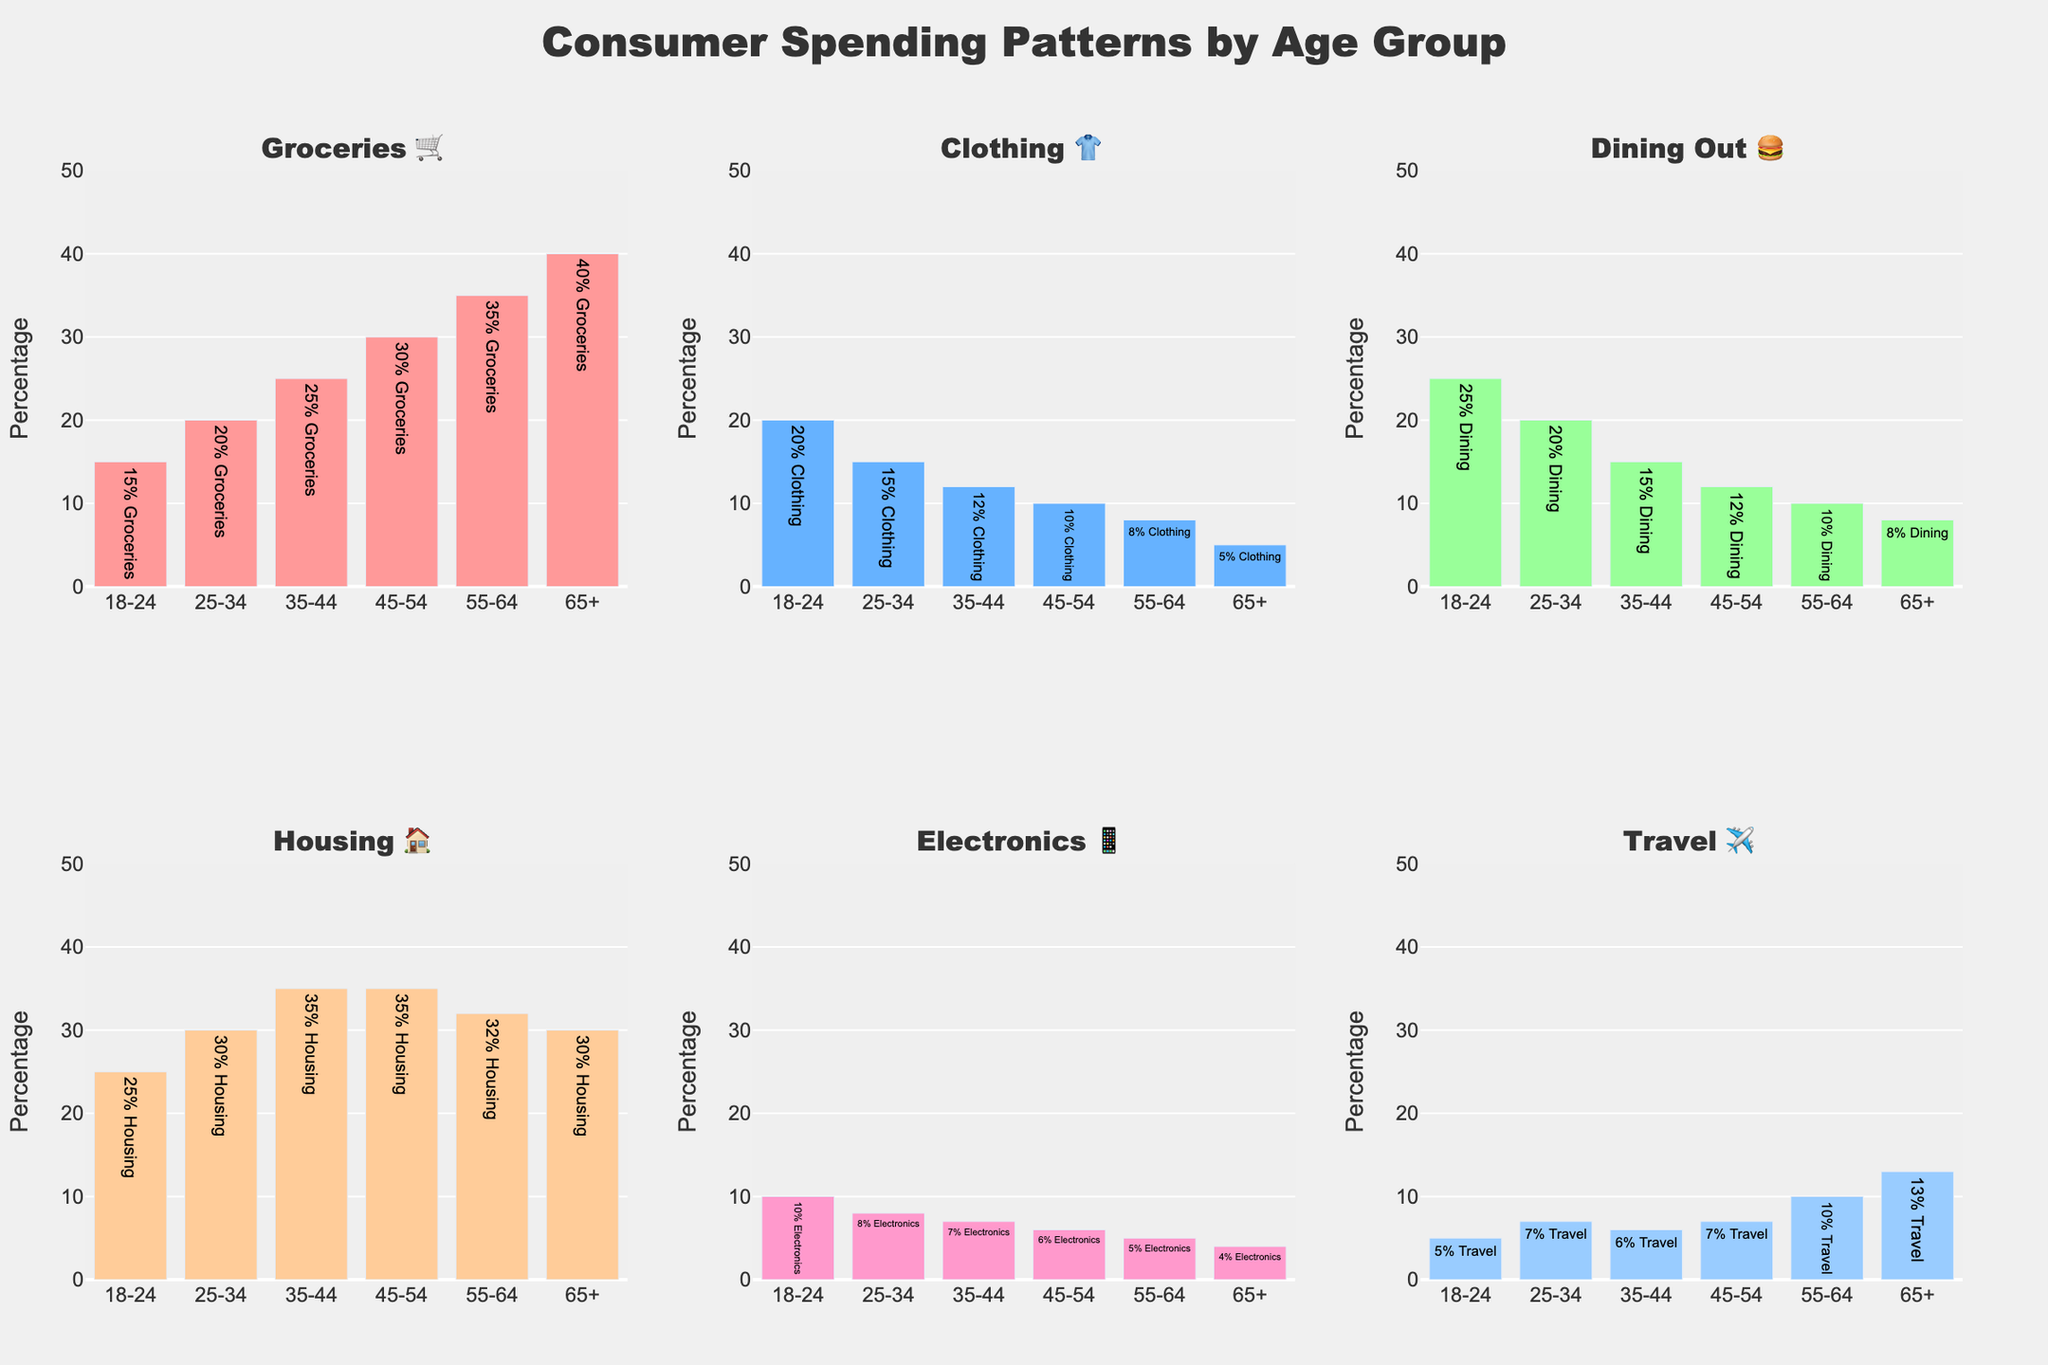What is the title of the figure? The title is typically found at the top of the chart and summarizes the content. Here it is located at the top-center.
Answer: Consumer Spending Patterns by Age Group Which age group spends the highest percentage on groceries 🛒? To find this, check the 'Groceries 🛒' sub-chart and see which age group's bar is the highest. The age group '65+' has the highest percentage, which is 40%.
Answer: 65+ What is the difference in percentage spent on dining out 🍔 between the age groups 18-24 and 55-64? Look at the 'Dining Out 🍔' sub-chart to compare the 25% for the 18-24 group and 10% for the 55-64 group. Calculate the difference as 25% - 10% = 15%.
Answer: 15% Which category has the lowest percentage of spending across all age groups? Compare the lowest values in each sub-chart. The lowest value is for Electronics 📱 in the 65+ age group, at 4%.
Answer: Electronics 📱 in 65+ Which age group spends the most on travel ✈️? Refer to the 'Travel ✈️' sub-chart to determine which age group has the highest bar. The 65+ age group spends 13% on travel, which is the highest.
Answer: 65+ Compare the percentage of spending on housing 🏠 between the 25-34 and 45-54 age groups. Check the 'Housing 🏠' sub-chart. Both age groups spend 35% on housing, so there is no difference.
Answer: Equal (35%) Is the spending on electronics 📱 increasing or decreasing with age? Observe the 'Electronics 📱' sub-chart from the left to right; the percentages decrease as the age groups get older, from 10% to 4%.
Answer: Decreasing Summarize the trend in dining out 🍔 spending as age increases. In the 'Dining Out 🍔' sub-chart, observe that the spending decreases as age increases, going from 25% (18-24) to 8% (65+).
Answer: Decreasing What is the total percentage of spending on clothing 👕 and dining out 🍔 for the 35-44 age group? For the 35-44 group, add the percentages for Clothing (12%) and Dining Out (15%): 12% + 15% = 27%.
Answer: 27% Which age group has the highest spending on housing 🏠 and what is its percentage? Locate the highest bar in the 'Housing 🏠' sub-chart. Both 35-44 and 45-54 age groups spend 35%, which is the highest.
Answer: 35-44 and 45-54 (35%) 